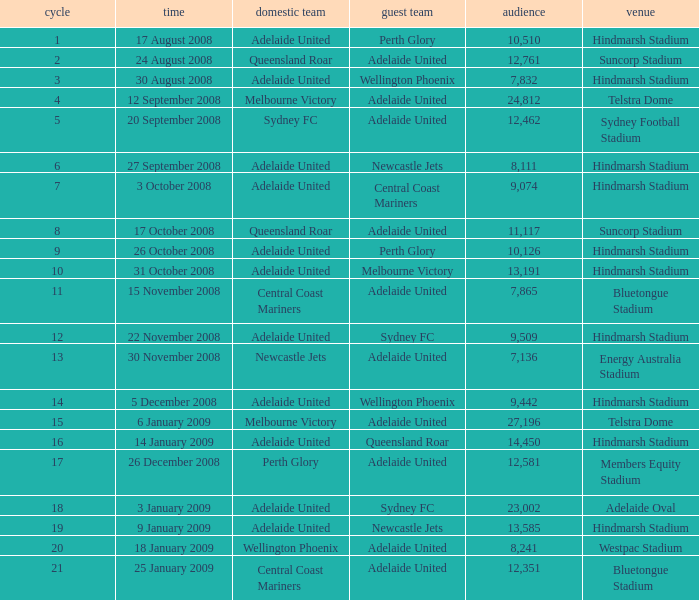What is the round when 11,117 people attended the game on 26 October 2008? 9.0. 